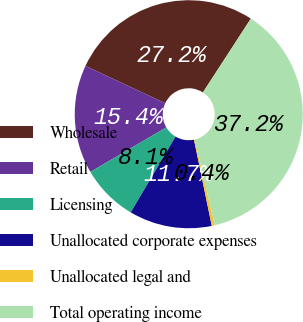Convert chart to OTSL. <chart><loc_0><loc_0><loc_500><loc_500><pie_chart><fcel>Wholesale<fcel>Retail<fcel>Licensing<fcel>Unallocated corporate expenses<fcel>Unallocated legal and<fcel>Total operating income<nl><fcel>27.2%<fcel>15.41%<fcel>8.06%<fcel>11.73%<fcel>0.43%<fcel>37.16%<nl></chart> 